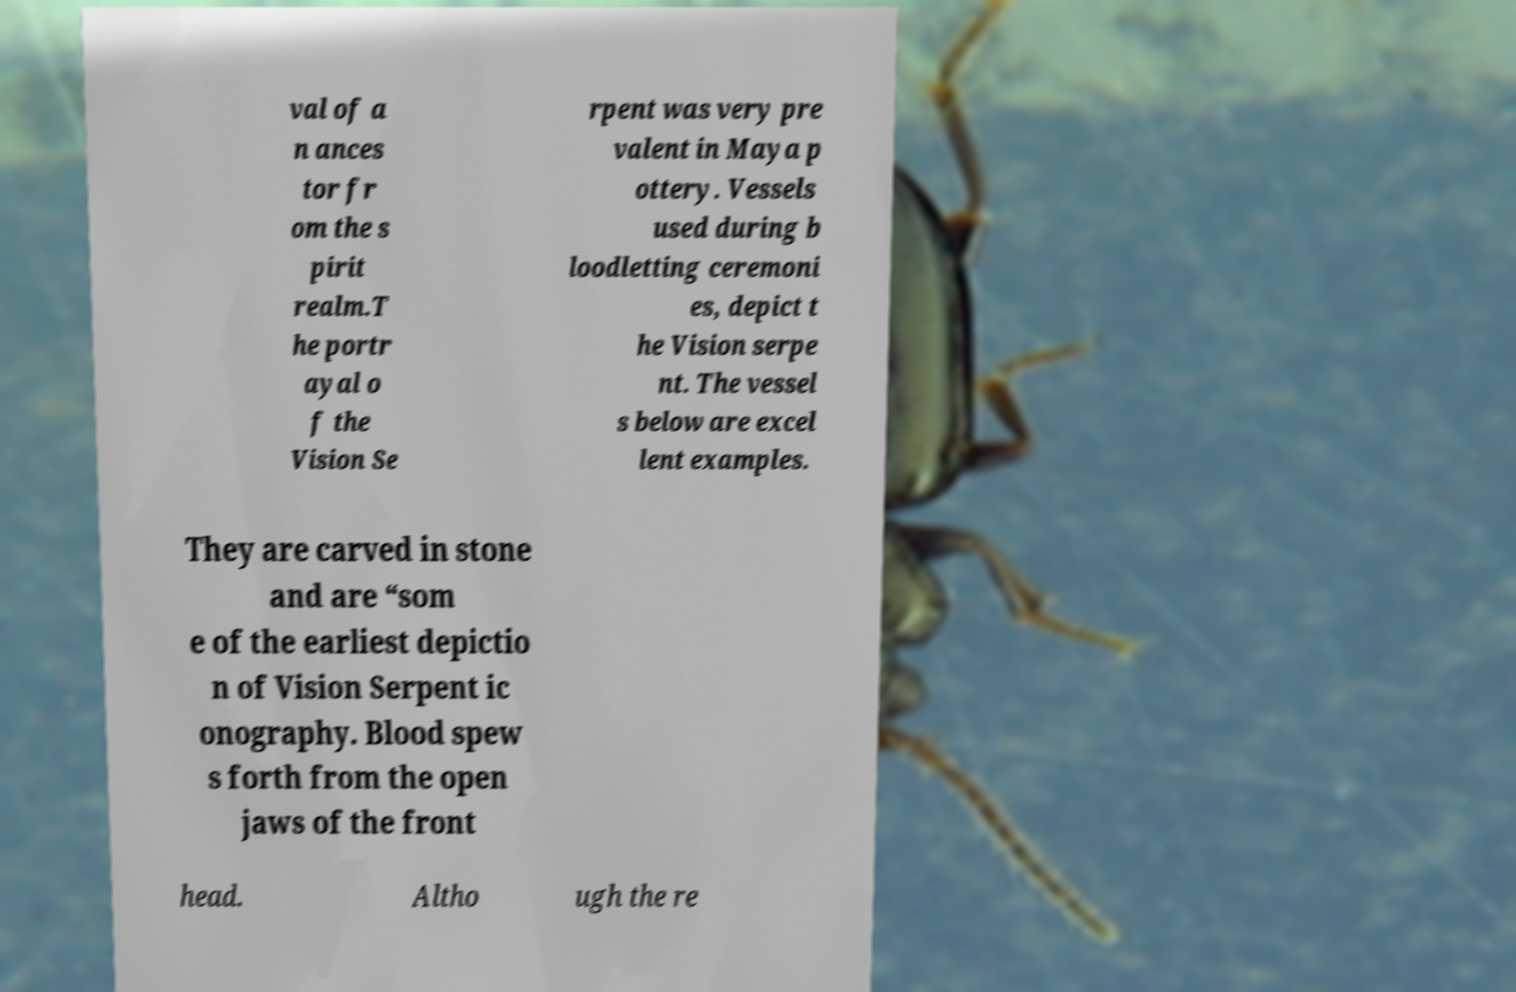Could you extract and type out the text from this image? val of a n ances tor fr om the s pirit realm.T he portr ayal o f the Vision Se rpent was very pre valent in Maya p ottery. Vessels used during b loodletting ceremoni es, depict t he Vision serpe nt. The vessel s below are excel lent examples. They are carved in stone and are “som e of the earliest depictio n of Vision Serpent ic onography. Blood spew s forth from the open jaws of the front head. Altho ugh the re 